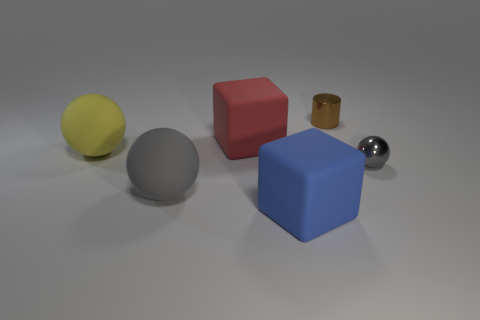Is the number of shiny cylinders on the left side of the yellow ball greater than the number of big rubber things?
Provide a succinct answer. No. Does the gray thing that is to the right of the blue block have the same shape as the red object?
Ensure brevity in your answer.  No. What number of cyan things are metal cylinders or big spheres?
Provide a succinct answer. 0. Are there more large purple shiny cylinders than large yellow objects?
Your answer should be very brief. No. What is the color of the metallic ball that is the same size as the metal cylinder?
Provide a succinct answer. Gray. What number of spheres are matte things or large yellow things?
Your answer should be compact. 2. There is a blue object; is its shape the same as the tiny metallic object behind the large red object?
Offer a terse response. No. What number of gray things are the same size as the yellow object?
Keep it short and to the point. 1. Does the rubber thing that is behind the big yellow thing have the same shape as the tiny metallic thing in front of the yellow matte object?
Give a very brief answer. No. What is the color of the small thing to the left of the small metallic object in front of the big red cube?
Keep it short and to the point. Brown. 